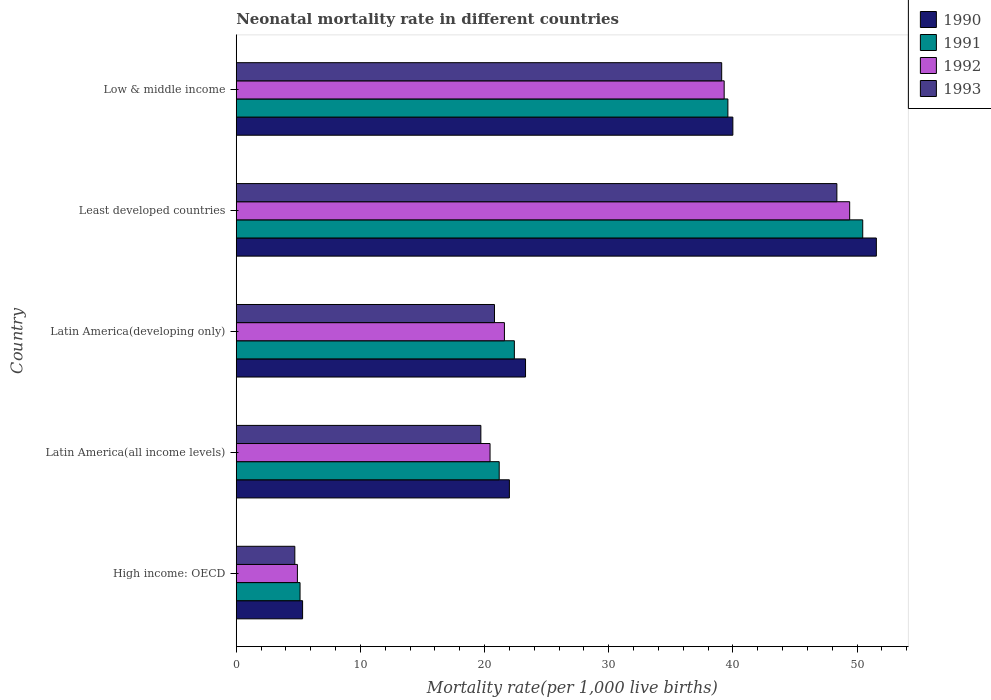How many different coloured bars are there?
Offer a terse response. 4. How many groups of bars are there?
Make the answer very short. 5. Are the number of bars per tick equal to the number of legend labels?
Give a very brief answer. Yes. How many bars are there on the 5th tick from the top?
Your answer should be compact. 4. What is the label of the 2nd group of bars from the top?
Your answer should be very brief. Least developed countries. Across all countries, what is the maximum neonatal mortality rate in 1992?
Provide a short and direct response. 49.41. Across all countries, what is the minimum neonatal mortality rate in 1992?
Give a very brief answer. 4.93. In which country was the neonatal mortality rate in 1991 maximum?
Provide a short and direct response. Least developed countries. In which country was the neonatal mortality rate in 1992 minimum?
Provide a short and direct response. High income: OECD. What is the total neonatal mortality rate in 1993 in the graph?
Provide a succinct answer. 132.7. What is the difference between the neonatal mortality rate in 1990 in High income: OECD and that in Latin America(developing only)?
Provide a short and direct response. -17.96. What is the difference between the neonatal mortality rate in 1993 in Latin America(all income levels) and the neonatal mortality rate in 1990 in High income: OECD?
Keep it short and to the point. 14.36. What is the average neonatal mortality rate in 1992 per country?
Offer a very short reply. 27.14. What is the difference between the neonatal mortality rate in 1991 and neonatal mortality rate in 1993 in High income: OECD?
Make the answer very short. 0.42. What is the ratio of the neonatal mortality rate in 1990 in Latin America(developing only) to that in Least developed countries?
Provide a succinct answer. 0.45. What is the difference between the highest and the second highest neonatal mortality rate in 1991?
Your response must be concise. 10.86. What is the difference between the highest and the lowest neonatal mortality rate in 1993?
Keep it short and to the point. 43.66. Is it the case that in every country, the sum of the neonatal mortality rate in 1991 and neonatal mortality rate in 1990 is greater than the neonatal mortality rate in 1992?
Ensure brevity in your answer.  Yes. Are all the bars in the graph horizontal?
Your answer should be compact. Yes. How many countries are there in the graph?
Provide a short and direct response. 5. What is the difference between two consecutive major ticks on the X-axis?
Make the answer very short. 10. Does the graph contain grids?
Ensure brevity in your answer.  No. Where does the legend appear in the graph?
Ensure brevity in your answer.  Top right. How many legend labels are there?
Ensure brevity in your answer.  4. How are the legend labels stacked?
Ensure brevity in your answer.  Vertical. What is the title of the graph?
Keep it short and to the point. Neonatal mortality rate in different countries. What is the label or title of the X-axis?
Offer a very short reply. Mortality rate(per 1,0 live births). What is the Mortality rate(per 1,000 live births) in 1990 in High income: OECD?
Provide a succinct answer. 5.34. What is the Mortality rate(per 1,000 live births) of 1991 in High income: OECD?
Provide a short and direct response. 5.14. What is the Mortality rate(per 1,000 live births) of 1992 in High income: OECD?
Keep it short and to the point. 4.93. What is the Mortality rate(per 1,000 live births) of 1993 in High income: OECD?
Provide a succinct answer. 4.72. What is the Mortality rate(per 1,000 live births) in 1990 in Latin America(all income levels)?
Provide a succinct answer. 22. What is the Mortality rate(per 1,000 live births) of 1991 in Latin America(all income levels)?
Offer a very short reply. 21.18. What is the Mortality rate(per 1,000 live births) of 1992 in Latin America(all income levels)?
Provide a succinct answer. 20.44. What is the Mortality rate(per 1,000 live births) in 1993 in Latin America(all income levels)?
Ensure brevity in your answer.  19.7. What is the Mortality rate(per 1,000 live births) in 1990 in Latin America(developing only)?
Give a very brief answer. 23.3. What is the Mortality rate(per 1,000 live births) of 1991 in Latin America(developing only)?
Offer a terse response. 22.4. What is the Mortality rate(per 1,000 live births) of 1992 in Latin America(developing only)?
Ensure brevity in your answer.  21.6. What is the Mortality rate(per 1,000 live births) of 1993 in Latin America(developing only)?
Offer a terse response. 20.8. What is the Mortality rate(per 1,000 live births) in 1990 in Least developed countries?
Keep it short and to the point. 51.56. What is the Mortality rate(per 1,000 live births) in 1991 in Least developed countries?
Provide a short and direct response. 50.46. What is the Mortality rate(per 1,000 live births) in 1992 in Least developed countries?
Make the answer very short. 49.41. What is the Mortality rate(per 1,000 live births) in 1993 in Least developed countries?
Offer a terse response. 48.38. What is the Mortality rate(per 1,000 live births) of 1990 in Low & middle income?
Your answer should be very brief. 40. What is the Mortality rate(per 1,000 live births) of 1991 in Low & middle income?
Your answer should be compact. 39.6. What is the Mortality rate(per 1,000 live births) of 1992 in Low & middle income?
Your answer should be compact. 39.3. What is the Mortality rate(per 1,000 live births) in 1993 in Low & middle income?
Your answer should be very brief. 39.1. Across all countries, what is the maximum Mortality rate(per 1,000 live births) of 1990?
Ensure brevity in your answer.  51.56. Across all countries, what is the maximum Mortality rate(per 1,000 live births) of 1991?
Your response must be concise. 50.46. Across all countries, what is the maximum Mortality rate(per 1,000 live births) in 1992?
Your answer should be very brief. 49.41. Across all countries, what is the maximum Mortality rate(per 1,000 live births) in 1993?
Provide a short and direct response. 48.38. Across all countries, what is the minimum Mortality rate(per 1,000 live births) of 1990?
Ensure brevity in your answer.  5.34. Across all countries, what is the minimum Mortality rate(per 1,000 live births) in 1991?
Offer a terse response. 5.14. Across all countries, what is the minimum Mortality rate(per 1,000 live births) of 1992?
Your answer should be very brief. 4.93. Across all countries, what is the minimum Mortality rate(per 1,000 live births) in 1993?
Your answer should be very brief. 4.72. What is the total Mortality rate(per 1,000 live births) of 1990 in the graph?
Provide a short and direct response. 142.2. What is the total Mortality rate(per 1,000 live births) of 1991 in the graph?
Make the answer very short. 138.78. What is the total Mortality rate(per 1,000 live births) in 1992 in the graph?
Offer a terse response. 135.68. What is the total Mortality rate(per 1,000 live births) of 1993 in the graph?
Your response must be concise. 132.7. What is the difference between the Mortality rate(per 1,000 live births) in 1990 in High income: OECD and that in Latin America(all income levels)?
Provide a short and direct response. -16.66. What is the difference between the Mortality rate(per 1,000 live births) of 1991 in High income: OECD and that in Latin America(all income levels)?
Your response must be concise. -16.04. What is the difference between the Mortality rate(per 1,000 live births) of 1992 in High income: OECD and that in Latin America(all income levels)?
Ensure brevity in your answer.  -15.52. What is the difference between the Mortality rate(per 1,000 live births) in 1993 in High income: OECD and that in Latin America(all income levels)?
Keep it short and to the point. -14.98. What is the difference between the Mortality rate(per 1,000 live births) in 1990 in High income: OECD and that in Latin America(developing only)?
Provide a succinct answer. -17.96. What is the difference between the Mortality rate(per 1,000 live births) of 1991 in High income: OECD and that in Latin America(developing only)?
Offer a very short reply. -17.26. What is the difference between the Mortality rate(per 1,000 live births) in 1992 in High income: OECD and that in Latin America(developing only)?
Your answer should be compact. -16.67. What is the difference between the Mortality rate(per 1,000 live births) of 1993 in High income: OECD and that in Latin America(developing only)?
Provide a succinct answer. -16.08. What is the difference between the Mortality rate(per 1,000 live births) in 1990 in High income: OECD and that in Least developed countries?
Ensure brevity in your answer.  -46.22. What is the difference between the Mortality rate(per 1,000 live births) of 1991 in High income: OECD and that in Least developed countries?
Give a very brief answer. -45.32. What is the difference between the Mortality rate(per 1,000 live births) in 1992 in High income: OECD and that in Least developed countries?
Keep it short and to the point. -44.48. What is the difference between the Mortality rate(per 1,000 live births) in 1993 in High income: OECD and that in Least developed countries?
Your response must be concise. -43.66. What is the difference between the Mortality rate(per 1,000 live births) of 1990 in High income: OECD and that in Low & middle income?
Offer a very short reply. -34.66. What is the difference between the Mortality rate(per 1,000 live births) in 1991 in High income: OECD and that in Low & middle income?
Make the answer very short. -34.46. What is the difference between the Mortality rate(per 1,000 live births) of 1992 in High income: OECD and that in Low & middle income?
Your answer should be compact. -34.37. What is the difference between the Mortality rate(per 1,000 live births) in 1993 in High income: OECD and that in Low & middle income?
Provide a succinct answer. -34.38. What is the difference between the Mortality rate(per 1,000 live births) of 1990 in Latin America(all income levels) and that in Latin America(developing only)?
Provide a succinct answer. -1.3. What is the difference between the Mortality rate(per 1,000 live births) of 1991 in Latin America(all income levels) and that in Latin America(developing only)?
Provide a short and direct response. -1.22. What is the difference between the Mortality rate(per 1,000 live births) of 1992 in Latin America(all income levels) and that in Latin America(developing only)?
Make the answer very short. -1.16. What is the difference between the Mortality rate(per 1,000 live births) of 1993 in Latin America(all income levels) and that in Latin America(developing only)?
Offer a very short reply. -1.1. What is the difference between the Mortality rate(per 1,000 live births) in 1990 in Latin America(all income levels) and that in Least developed countries?
Give a very brief answer. -29.56. What is the difference between the Mortality rate(per 1,000 live births) of 1991 in Latin America(all income levels) and that in Least developed countries?
Offer a very short reply. -29.28. What is the difference between the Mortality rate(per 1,000 live births) in 1992 in Latin America(all income levels) and that in Least developed countries?
Keep it short and to the point. -28.97. What is the difference between the Mortality rate(per 1,000 live births) of 1993 in Latin America(all income levels) and that in Least developed countries?
Ensure brevity in your answer.  -28.68. What is the difference between the Mortality rate(per 1,000 live births) of 1990 in Latin America(all income levels) and that in Low & middle income?
Give a very brief answer. -18. What is the difference between the Mortality rate(per 1,000 live births) in 1991 in Latin America(all income levels) and that in Low & middle income?
Your answer should be very brief. -18.42. What is the difference between the Mortality rate(per 1,000 live births) in 1992 in Latin America(all income levels) and that in Low & middle income?
Provide a short and direct response. -18.86. What is the difference between the Mortality rate(per 1,000 live births) in 1993 in Latin America(all income levels) and that in Low & middle income?
Give a very brief answer. -19.4. What is the difference between the Mortality rate(per 1,000 live births) in 1990 in Latin America(developing only) and that in Least developed countries?
Provide a succinct answer. -28.26. What is the difference between the Mortality rate(per 1,000 live births) of 1991 in Latin America(developing only) and that in Least developed countries?
Offer a very short reply. -28.06. What is the difference between the Mortality rate(per 1,000 live births) of 1992 in Latin America(developing only) and that in Least developed countries?
Provide a succinct answer. -27.81. What is the difference between the Mortality rate(per 1,000 live births) of 1993 in Latin America(developing only) and that in Least developed countries?
Your response must be concise. -27.58. What is the difference between the Mortality rate(per 1,000 live births) of 1990 in Latin America(developing only) and that in Low & middle income?
Give a very brief answer. -16.7. What is the difference between the Mortality rate(per 1,000 live births) of 1991 in Latin America(developing only) and that in Low & middle income?
Your response must be concise. -17.2. What is the difference between the Mortality rate(per 1,000 live births) of 1992 in Latin America(developing only) and that in Low & middle income?
Offer a terse response. -17.7. What is the difference between the Mortality rate(per 1,000 live births) in 1993 in Latin America(developing only) and that in Low & middle income?
Your answer should be very brief. -18.3. What is the difference between the Mortality rate(per 1,000 live births) of 1990 in Least developed countries and that in Low & middle income?
Your response must be concise. 11.56. What is the difference between the Mortality rate(per 1,000 live births) of 1991 in Least developed countries and that in Low & middle income?
Provide a short and direct response. 10.86. What is the difference between the Mortality rate(per 1,000 live births) in 1992 in Least developed countries and that in Low & middle income?
Provide a short and direct response. 10.11. What is the difference between the Mortality rate(per 1,000 live births) of 1993 in Least developed countries and that in Low & middle income?
Your response must be concise. 9.28. What is the difference between the Mortality rate(per 1,000 live births) of 1990 in High income: OECD and the Mortality rate(per 1,000 live births) of 1991 in Latin America(all income levels)?
Your answer should be compact. -15.84. What is the difference between the Mortality rate(per 1,000 live births) of 1990 in High income: OECD and the Mortality rate(per 1,000 live births) of 1992 in Latin America(all income levels)?
Provide a succinct answer. -15.1. What is the difference between the Mortality rate(per 1,000 live births) in 1990 in High income: OECD and the Mortality rate(per 1,000 live births) in 1993 in Latin America(all income levels)?
Provide a succinct answer. -14.36. What is the difference between the Mortality rate(per 1,000 live births) in 1991 in High income: OECD and the Mortality rate(per 1,000 live births) in 1992 in Latin America(all income levels)?
Give a very brief answer. -15.3. What is the difference between the Mortality rate(per 1,000 live births) in 1991 in High income: OECD and the Mortality rate(per 1,000 live births) in 1993 in Latin America(all income levels)?
Your answer should be compact. -14.56. What is the difference between the Mortality rate(per 1,000 live births) of 1992 in High income: OECD and the Mortality rate(per 1,000 live births) of 1993 in Latin America(all income levels)?
Ensure brevity in your answer.  -14.78. What is the difference between the Mortality rate(per 1,000 live births) of 1990 in High income: OECD and the Mortality rate(per 1,000 live births) of 1991 in Latin America(developing only)?
Provide a short and direct response. -17.06. What is the difference between the Mortality rate(per 1,000 live births) of 1990 in High income: OECD and the Mortality rate(per 1,000 live births) of 1992 in Latin America(developing only)?
Give a very brief answer. -16.26. What is the difference between the Mortality rate(per 1,000 live births) in 1990 in High income: OECD and the Mortality rate(per 1,000 live births) in 1993 in Latin America(developing only)?
Ensure brevity in your answer.  -15.46. What is the difference between the Mortality rate(per 1,000 live births) in 1991 in High income: OECD and the Mortality rate(per 1,000 live births) in 1992 in Latin America(developing only)?
Your answer should be very brief. -16.46. What is the difference between the Mortality rate(per 1,000 live births) of 1991 in High income: OECD and the Mortality rate(per 1,000 live births) of 1993 in Latin America(developing only)?
Provide a succinct answer. -15.66. What is the difference between the Mortality rate(per 1,000 live births) in 1992 in High income: OECD and the Mortality rate(per 1,000 live births) in 1993 in Latin America(developing only)?
Make the answer very short. -15.87. What is the difference between the Mortality rate(per 1,000 live births) of 1990 in High income: OECD and the Mortality rate(per 1,000 live births) of 1991 in Least developed countries?
Provide a short and direct response. -45.12. What is the difference between the Mortality rate(per 1,000 live births) in 1990 in High income: OECD and the Mortality rate(per 1,000 live births) in 1992 in Least developed countries?
Your answer should be compact. -44.07. What is the difference between the Mortality rate(per 1,000 live births) in 1990 in High income: OECD and the Mortality rate(per 1,000 live births) in 1993 in Least developed countries?
Offer a terse response. -43.03. What is the difference between the Mortality rate(per 1,000 live births) of 1991 in High income: OECD and the Mortality rate(per 1,000 live births) of 1992 in Least developed countries?
Make the answer very short. -44.27. What is the difference between the Mortality rate(per 1,000 live births) of 1991 in High income: OECD and the Mortality rate(per 1,000 live births) of 1993 in Least developed countries?
Your response must be concise. -43.24. What is the difference between the Mortality rate(per 1,000 live births) in 1992 in High income: OECD and the Mortality rate(per 1,000 live births) in 1993 in Least developed countries?
Provide a succinct answer. -43.45. What is the difference between the Mortality rate(per 1,000 live births) in 1990 in High income: OECD and the Mortality rate(per 1,000 live births) in 1991 in Low & middle income?
Offer a very short reply. -34.26. What is the difference between the Mortality rate(per 1,000 live births) in 1990 in High income: OECD and the Mortality rate(per 1,000 live births) in 1992 in Low & middle income?
Your answer should be compact. -33.96. What is the difference between the Mortality rate(per 1,000 live births) of 1990 in High income: OECD and the Mortality rate(per 1,000 live births) of 1993 in Low & middle income?
Make the answer very short. -33.76. What is the difference between the Mortality rate(per 1,000 live births) of 1991 in High income: OECD and the Mortality rate(per 1,000 live births) of 1992 in Low & middle income?
Offer a very short reply. -34.16. What is the difference between the Mortality rate(per 1,000 live births) in 1991 in High income: OECD and the Mortality rate(per 1,000 live births) in 1993 in Low & middle income?
Offer a terse response. -33.96. What is the difference between the Mortality rate(per 1,000 live births) of 1992 in High income: OECD and the Mortality rate(per 1,000 live births) of 1993 in Low & middle income?
Offer a terse response. -34.17. What is the difference between the Mortality rate(per 1,000 live births) in 1990 in Latin America(all income levels) and the Mortality rate(per 1,000 live births) in 1991 in Latin America(developing only)?
Your answer should be very brief. -0.4. What is the difference between the Mortality rate(per 1,000 live births) in 1990 in Latin America(all income levels) and the Mortality rate(per 1,000 live births) in 1992 in Latin America(developing only)?
Your answer should be compact. 0.4. What is the difference between the Mortality rate(per 1,000 live births) of 1990 in Latin America(all income levels) and the Mortality rate(per 1,000 live births) of 1993 in Latin America(developing only)?
Ensure brevity in your answer.  1.2. What is the difference between the Mortality rate(per 1,000 live births) of 1991 in Latin America(all income levels) and the Mortality rate(per 1,000 live births) of 1992 in Latin America(developing only)?
Offer a very short reply. -0.42. What is the difference between the Mortality rate(per 1,000 live births) of 1991 in Latin America(all income levels) and the Mortality rate(per 1,000 live births) of 1993 in Latin America(developing only)?
Offer a very short reply. 0.38. What is the difference between the Mortality rate(per 1,000 live births) in 1992 in Latin America(all income levels) and the Mortality rate(per 1,000 live births) in 1993 in Latin America(developing only)?
Keep it short and to the point. -0.36. What is the difference between the Mortality rate(per 1,000 live births) of 1990 in Latin America(all income levels) and the Mortality rate(per 1,000 live births) of 1991 in Least developed countries?
Offer a very short reply. -28.46. What is the difference between the Mortality rate(per 1,000 live births) in 1990 in Latin America(all income levels) and the Mortality rate(per 1,000 live births) in 1992 in Least developed countries?
Your response must be concise. -27.41. What is the difference between the Mortality rate(per 1,000 live births) of 1990 in Latin America(all income levels) and the Mortality rate(per 1,000 live births) of 1993 in Least developed countries?
Keep it short and to the point. -26.38. What is the difference between the Mortality rate(per 1,000 live births) of 1991 in Latin America(all income levels) and the Mortality rate(per 1,000 live births) of 1992 in Least developed countries?
Give a very brief answer. -28.23. What is the difference between the Mortality rate(per 1,000 live births) of 1991 in Latin America(all income levels) and the Mortality rate(per 1,000 live births) of 1993 in Least developed countries?
Give a very brief answer. -27.2. What is the difference between the Mortality rate(per 1,000 live births) in 1992 in Latin America(all income levels) and the Mortality rate(per 1,000 live births) in 1993 in Least developed countries?
Provide a succinct answer. -27.94. What is the difference between the Mortality rate(per 1,000 live births) of 1990 in Latin America(all income levels) and the Mortality rate(per 1,000 live births) of 1991 in Low & middle income?
Provide a succinct answer. -17.6. What is the difference between the Mortality rate(per 1,000 live births) in 1990 in Latin America(all income levels) and the Mortality rate(per 1,000 live births) in 1992 in Low & middle income?
Your answer should be very brief. -17.3. What is the difference between the Mortality rate(per 1,000 live births) in 1990 in Latin America(all income levels) and the Mortality rate(per 1,000 live births) in 1993 in Low & middle income?
Make the answer very short. -17.1. What is the difference between the Mortality rate(per 1,000 live births) in 1991 in Latin America(all income levels) and the Mortality rate(per 1,000 live births) in 1992 in Low & middle income?
Provide a succinct answer. -18.12. What is the difference between the Mortality rate(per 1,000 live births) of 1991 in Latin America(all income levels) and the Mortality rate(per 1,000 live births) of 1993 in Low & middle income?
Make the answer very short. -17.92. What is the difference between the Mortality rate(per 1,000 live births) of 1992 in Latin America(all income levels) and the Mortality rate(per 1,000 live births) of 1993 in Low & middle income?
Your response must be concise. -18.66. What is the difference between the Mortality rate(per 1,000 live births) of 1990 in Latin America(developing only) and the Mortality rate(per 1,000 live births) of 1991 in Least developed countries?
Your answer should be very brief. -27.16. What is the difference between the Mortality rate(per 1,000 live births) of 1990 in Latin America(developing only) and the Mortality rate(per 1,000 live births) of 1992 in Least developed countries?
Provide a short and direct response. -26.11. What is the difference between the Mortality rate(per 1,000 live births) of 1990 in Latin America(developing only) and the Mortality rate(per 1,000 live births) of 1993 in Least developed countries?
Make the answer very short. -25.08. What is the difference between the Mortality rate(per 1,000 live births) of 1991 in Latin America(developing only) and the Mortality rate(per 1,000 live births) of 1992 in Least developed countries?
Make the answer very short. -27.01. What is the difference between the Mortality rate(per 1,000 live births) of 1991 in Latin America(developing only) and the Mortality rate(per 1,000 live births) of 1993 in Least developed countries?
Provide a short and direct response. -25.98. What is the difference between the Mortality rate(per 1,000 live births) in 1992 in Latin America(developing only) and the Mortality rate(per 1,000 live births) in 1993 in Least developed countries?
Offer a terse response. -26.78. What is the difference between the Mortality rate(per 1,000 live births) of 1990 in Latin America(developing only) and the Mortality rate(per 1,000 live births) of 1991 in Low & middle income?
Your answer should be compact. -16.3. What is the difference between the Mortality rate(per 1,000 live births) in 1990 in Latin America(developing only) and the Mortality rate(per 1,000 live births) in 1992 in Low & middle income?
Your answer should be compact. -16. What is the difference between the Mortality rate(per 1,000 live births) of 1990 in Latin America(developing only) and the Mortality rate(per 1,000 live births) of 1993 in Low & middle income?
Your answer should be compact. -15.8. What is the difference between the Mortality rate(per 1,000 live births) of 1991 in Latin America(developing only) and the Mortality rate(per 1,000 live births) of 1992 in Low & middle income?
Your response must be concise. -16.9. What is the difference between the Mortality rate(per 1,000 live births) of 1991 in Latin America(developing only) and the Mortality rate(per 1,000 live births) of 1993 in Low & middle income?
Give a very brief answer. -16.7. What is the difference between the Mortality rate(per 1,000 live births) of 1992 in Latin America(developing only) and the Mortality rate(per 1,000 live births) of 1993 in Low & middle income?
Provide a short and direct response. -17.5. What is the difference between the Mortality rate(per 1,000 live births) of 1990 in Least developed countries and the Mortality rate(per 1,000 live births) of 1991 in Low & middle income?
Provide a succinct answer. 11.96. What is the difference between the Mortality rate(per 1,000 live births) of 1990 in Least developed countries and the Mortality rate(per 1,000 live births) of 1992 in Low & middle income?
Your answer should be compact. 12.26. What is the difference between the Mortality rate(per 1,000 live births) in 1990 in Least developed countries and the Mortality rate(per 1,000 live births) in 1993 in Low & middle income?
Your answer should be compact. 12.46. What is the difference between the Mortality rate(per 1,000 live births) of 1991 in Least developed countries and the Mortality rate(per 1,000 live births) of 1992 in Low & middle income?
Provide a succinct answer. 11.16. What is the difference between the Mortality rate(per 1,000 live births) of 1991 in Least developed countries and the Mortality rate(per 1,000 live births) of 1993 in Low & middle income?
Offer a very short reply. 11.36. What is the difference between the Mortality rate(per 1,000 live births) in 1992 in Least developed countries and the Mortality rate(per 1,000 live births) in 1993 in Low & middle income?
Make the answer very short. 10.31. What is the average Mortality rate(per 1,000 live births) of 1990 per country?
Your response must be concise. 28.44. What is the average Mortality rate(per 1,000 live births) in 1991 per country?
Your answer should be very brief. 27.76. What is the average Mortality rate(per 1,000 live births) in 1992 per country?
Offer a very short reply. 27.14. What is the average Mortality rate(per 1,000 live births) in 1993 per country?
Give a very brief answer. 26.54. What is the difference between the Mortality rate(per 1,000 live births) of 1990 and Mortality rate(per 1,000 live births) of 1991 in High income: OECD?
Your answer should be compact. 0.21. What is the difference between the Mortality rate(per 1,000 live births) of 1990 and Mortality rate(per 1,000 live births) of 1992 in High income: OECD?
Your answer should be compact. 0.42. What is the difference between the Mortality rate(per 1,000 live births) in 1990 and Mortality rate(per 1,000 live births) in 1993 in High income: OECD?
Provide a short and direct response. 0.63. What is the difference between the Mortality rate(per 1,000 live births) in 1991 and Mortality rate(per 1,000 live births) in 1992 in High income: OECD?
Your response must be concise. 0.21. What is the difference between the Mortality rate(per 1,000 live births) of 1991 and Mortality rate(per 1,000 live births) of 1993 in High income: OECD?
Provide a succinct answer. 0.42. What is the difference between the Mortality rate(per 1,000 live births) in 1992 and Mortality rate(per 1,000 live births) in 1993 in High income: OECD?
Make the answer very short. 0.21. What is the difference between the Mortality rate(per 1,000 live births) of 1990 and Mortality rate(per 1,000 live births) of 1991 in Latin America(all income levels)?
Ensure brevity in your answer.  0.82. What is the difference between the Mortality rate(per 1,000 live births) in 1990 and Mortality rate(per 1,000 live births) in 1992 in Latin America(all income levels)?
Offer a very short reply. 1.56. What is the difference between the Mortality rate(per 1,000 live births) of 1990 and Mortality rate(per 1,000 live births) of 1993 in Latin America(all income levels)?
Make the answer very short. 2.3. What is the difference between the Mortality rate(per 1,000 live births) of 1991 and Mortality rate(per 1,000 live births) of 1992 in Latin America(all income levels)?
Give a very brief answer. 0.74. What is the difference between the Mortality rate(per 1,000 live births) in 1991 and Mortality rate(per 1,000 live births) in 1993 in Latin America(all income levels)?
Your answer should be compact. 1.48. What is the difference between the Mortality rate(per 1,000 live births) of 1992 and Mortality rate(per 1,000 live births) of 1993 in Latin America(all income levels)?
Offer a very short reply. 0.74. What is the difference between the Mortality rate(per 1,000 live births) in 1990 and Mortality rate(per 1,000 live births) in 1991 in Latin America(developing only)?
Provide a short and direct response. 0.9. What is the difference between the Mortality rate(per 1,000 live births) in 1990 and Mortality rate(per 1,000 live births) in 1991 in Least developed countries?
Offer a terse response. 1.1. What is the difference between the Mortality rate(per 1,000 live births) in 1990 and Mortality rate(per 1,000 live births) in 1992 in Least developed countries?
Offer a very short reply. 2.15. What is the difference between the Mortality rate(per 1,000 live births) of 1990 and Mortality rate(per 1,000 live births) of 1993 in Least developed countries?
Ensure brevity in your answer.  3.18. What is the difference between the Mortality rate(per 1,000 live births) in 1991 and Mortality rate(per 1,000 live births) in 1992 in Least developed countries?
Offer a very short reply. 1.05. What is the difference between the Mortality rate(per 1,000 live births) in 1991 and Mortality rate(per 1,000 live births) in 1993 in Least developed countries?
Offer a very short reply. 2.08. What is the difference between the Mortality rate(per 1,000 live births) of 1992 and Mortality rate(per 1,000 live births) of 1993 in Least developed countries?
Provide a succinct answer. 1.03. What is the difference between the Mortality rate(per 1,000 live births) in 1990 and Mortality rate(per 1,000 live births) in 1991 in Low & middle income?
Give a very brief answer. 0.4. What is the difference between the Mortality rate(per 1,000 live births) in 1990 and Mortality rate(per 1,000 live births) in 1992 in Low & middle income?
Offer a terse response. 0.7. What is the difference between the Mortality rate(per 1,000 live births) of 1992 and Mortality rate(per 1,000 live births) of 1993 in Low & middle income?
Your answer should be compact. 0.2. What is the ratio of the Mortality rate(per 1,000 live births) in 1990 in High income: OECD to that in Latin America(all income levels)?
Ensure brevity in your answer.  0.24. What is the ratio of the Mortality rate(per 1,000 live births) of 1991 in High income: OECD to that in Latin America(all income levels)?
Offer a terse response. 0.24. What is the ratio of the Mortality rate(per 1,000 live births) of 1992 in High income: OECD to that in Latin America(all income levels)?
Give a very brief answer. 0.24. What is the ratio of the Mortality rate(per 1,000 live births) of 1993 in High income: OECD to that in Latin America(all income levels)?
Offer a very short reply. 0.24. What is the ratio of the Mortality rate(per 1,000 live births) in 1990 in High income: OECD to that in Latin America(developing only)?
Make the answer very short. 0.23. What is the ratio of the Mortality rate(per 1,000 live births) of 1991 in High income: OECD to that in Latin America(developing only)?
Your answer should be compact. 0.23. What is the ratio of the Mortality rate(per 1,000 live births) of 1992 in High income: OECD to that in Latin America(developing only)?
Your answer should be compact. 0.23. What is the ratio of the Mortality rate(per 1,000 live births) in 1993 in High income: OECD to that in Latin America(developing only)?
Your answer should be very brief. 0.23. What is the ratio of the Mortality rate(per 1,000 live births) of 1990 in High income: OECD to that in Least developed countries?
Make the answer very short. 0.1. What is the ratio of the Mortality rate(per 1,000 live births) in 1991 in High income: OECD to that in Least developed countries?
Provide a short and direct response. 0.1. What is the ratio of the Mortality rate(per 1,000 live births) in 1992 in High income: OECD to that in Least developed countries?
Your answer should be very brief. 0.1. What is the ratio of the Mortality rate(per 1,000 live births) in 1993 in High income: OECD to that in Least developed countries?
Offer a terse response. 0.1. What is the ratio of the Mortality rate(per 1,000 live births) of 1990 in High income: OECD to that in Low & middle income?
Offer a terse response. 0.13. What is the ratio of the Mortality rate(per 1,000 live births) in 1991 in High income: OECD to that in Low & middle income?
Keep it short and to the point. 0.13. What is the ratio of the Mortality rate(per 1,000 live births) of 1992 in High income: OECD to that in Low & middle income?
Ensure brevity in your answer.  0.13. What is the ratio of the Mortality rate(per 1,000 live births) in 1993 in High income: OECD to that in Low & middle income?
Give a very brief answer. 0.12. What is the ratio of the Mortality rate(per 1,000 live births) in 1990 in Latin America(all income levels) to that in Latin America(developing only)?
Your answer should be very brief. 0.94. What is the ratio of the Mortality rate(per 1,000 live births) in 1991 in Latin America(all income levels) to that in Latin America(developing only)?
Offer a terse response. 0.95. What is the ratio of the Mortality rate(per 1,000 live births) in 1992 in Latin America(all income levels) to that in Latin America(developing only)?
Offer a very short reply. 0.95. What is the ratio of the Mortality rate(per 1,000 live births) of 1993 in Latin America(all income levels) to that in Latin America(developing only)?
Keep it short and to the point. 0.95. What is the ratio of the Mortality rate(per 1,000 live births) in 1990 in Latin America(all income levels) to that in Least developed countries?
Ensure brevity in your answer.  0.43. What is the ratio of the Mortality rate(per 1,000 live births) of 1991 in Latin America(all income levels) to that in Least developed countries?
Your answer should be very brief. 0.42. What is the ratio of the Mortality rate(per 1,000 live births) of 1992 in Latin America(all income levels) to that in Least developed countries?
Ensure brevity in your answer.  0.41. What is the ratio of the Mortality rate(per 1,000 live births) in 1993 in Latin America(all income levels) to that in Least developed countries?
Provide a short and direct response. 0.41. What is the ratio of the Mortality rate(per 1,000 live births) in 1990 in Latin America(all income levels) to that in Low & middle income?
Offer a terse response. 0.55. What is the ratio of the Mortality rate(per 1,000 live births) of 1991 in Latin America(all income levels) to that in Low & middle income?
Ensure brevity in your answer.  0.53. What is the ratio of the Mortality rate(per 1,000 live births) of 1992 in Latin America(all income levels) to that in Low & middle income?
Keep it short and to the point. 0.52. What is the ratio of the Mortality rate(per 1,000 live births) of 1993 in Latin America(all income levels) to that in Low & middle income?
Your answer should be very brief. 0.5. What is the ratio of the Mortality rate(per 1,000 live births) of 1990 in Latin America(developing only) to that in Least developed countries?
Your response must be concise. 0.45. What is the ratio of the Mortality rate(per 1,000 live births) of 1991 in Latin America(developing only) to that in Least developed countries?
Your answer should be very brief. 0.44. What is the ratio of the Mortality rate(per 1,000 live births) in 1992 in Latin America(developing only) to that in Least developed countries?
Give a very brief answer. 0.44. What is the ratio of the Mortality rate(per 1,000 live births) of 1993 in Latin America(developing only) to that in Least developed countries?
Provide a succinct answer. 0.43. What is the ratio of the Mortality rate(per 1,000 live births) of 1990 in Latin America(developing only) to that in Low & middle income?
Offer a very short reply. 0.58. What is the ratio of the Mortality rate(per 1,000 live births) of 1991 in Latin America(developing only) to that in Low & middle income?
Provide a succinct answer. 0.57. What is the ratio of the Mortality rate(per 1,000 live births) of 1992 in Latin America(developing only) to that in Low & middle income?
Your answer should be compact. 0.55. What is the ratio of the Mortality rate(per 1,000 live births) of 1993 in Latin America(developing only) to that in Low & middle income?
Give a very brief answer. 0.53. What is the ratio of the Mortality rate(per 1,000 live births) of 1990 in Least developed countries to that in Low & middle income?
Offer a very short reply. 1.29. What is the ratio of the Mortality rate(per 1,000 live births) in 1991 in Least developed countries to that in Low & middle income?
Give a very brief answer. 1.27. What is the ratio of the Mortality rate(per 1,000 live births) of 1992 in Least developed countries to that in Low & middle income?
Your response must be concise. 1.26. What is the ratio of the Mortality rate(per 1,000 live births) of 1993 in Least developed countries to that in Low & middle income?
Your answer should be very brief. 1.24. What is the difference between the highest and the second highest Mortality rate(per 1,000 live births) in 1990?
Offer a terse response. 11.56. What is the difference between the highest and the second highest Mortality rate(per 1,000 live births) of 1991?
Make the answer very short. 10.86. What is the difference between the highest and the second highest Mortality rate(per 1,000 live births) in 1992?
Your response must be concise. 10.11. What is the difference between the highest and the second highest Mortality rate(per 1,000 live births) of 1993?
Your answer should be compact. 9.28. What is the difference between the highest and the lowest Mortality rate(per 1,000 live births) in 1990?
Your answer should be compact. 46.22. What is the difference between the highest and the lowest Mortality rate(per 1,000 live births) in 1991?
Your response must be concise. 45.32. What is the difference between the highest and the lowest Mortality rate(per 1,000 live births) of 1992?
Offer a very short reply. 44.48. What is the difference between the highest and the lowest Mortality rate(per 1,000 live births) in 1993?
Keep it short and to the point. 43.66. 